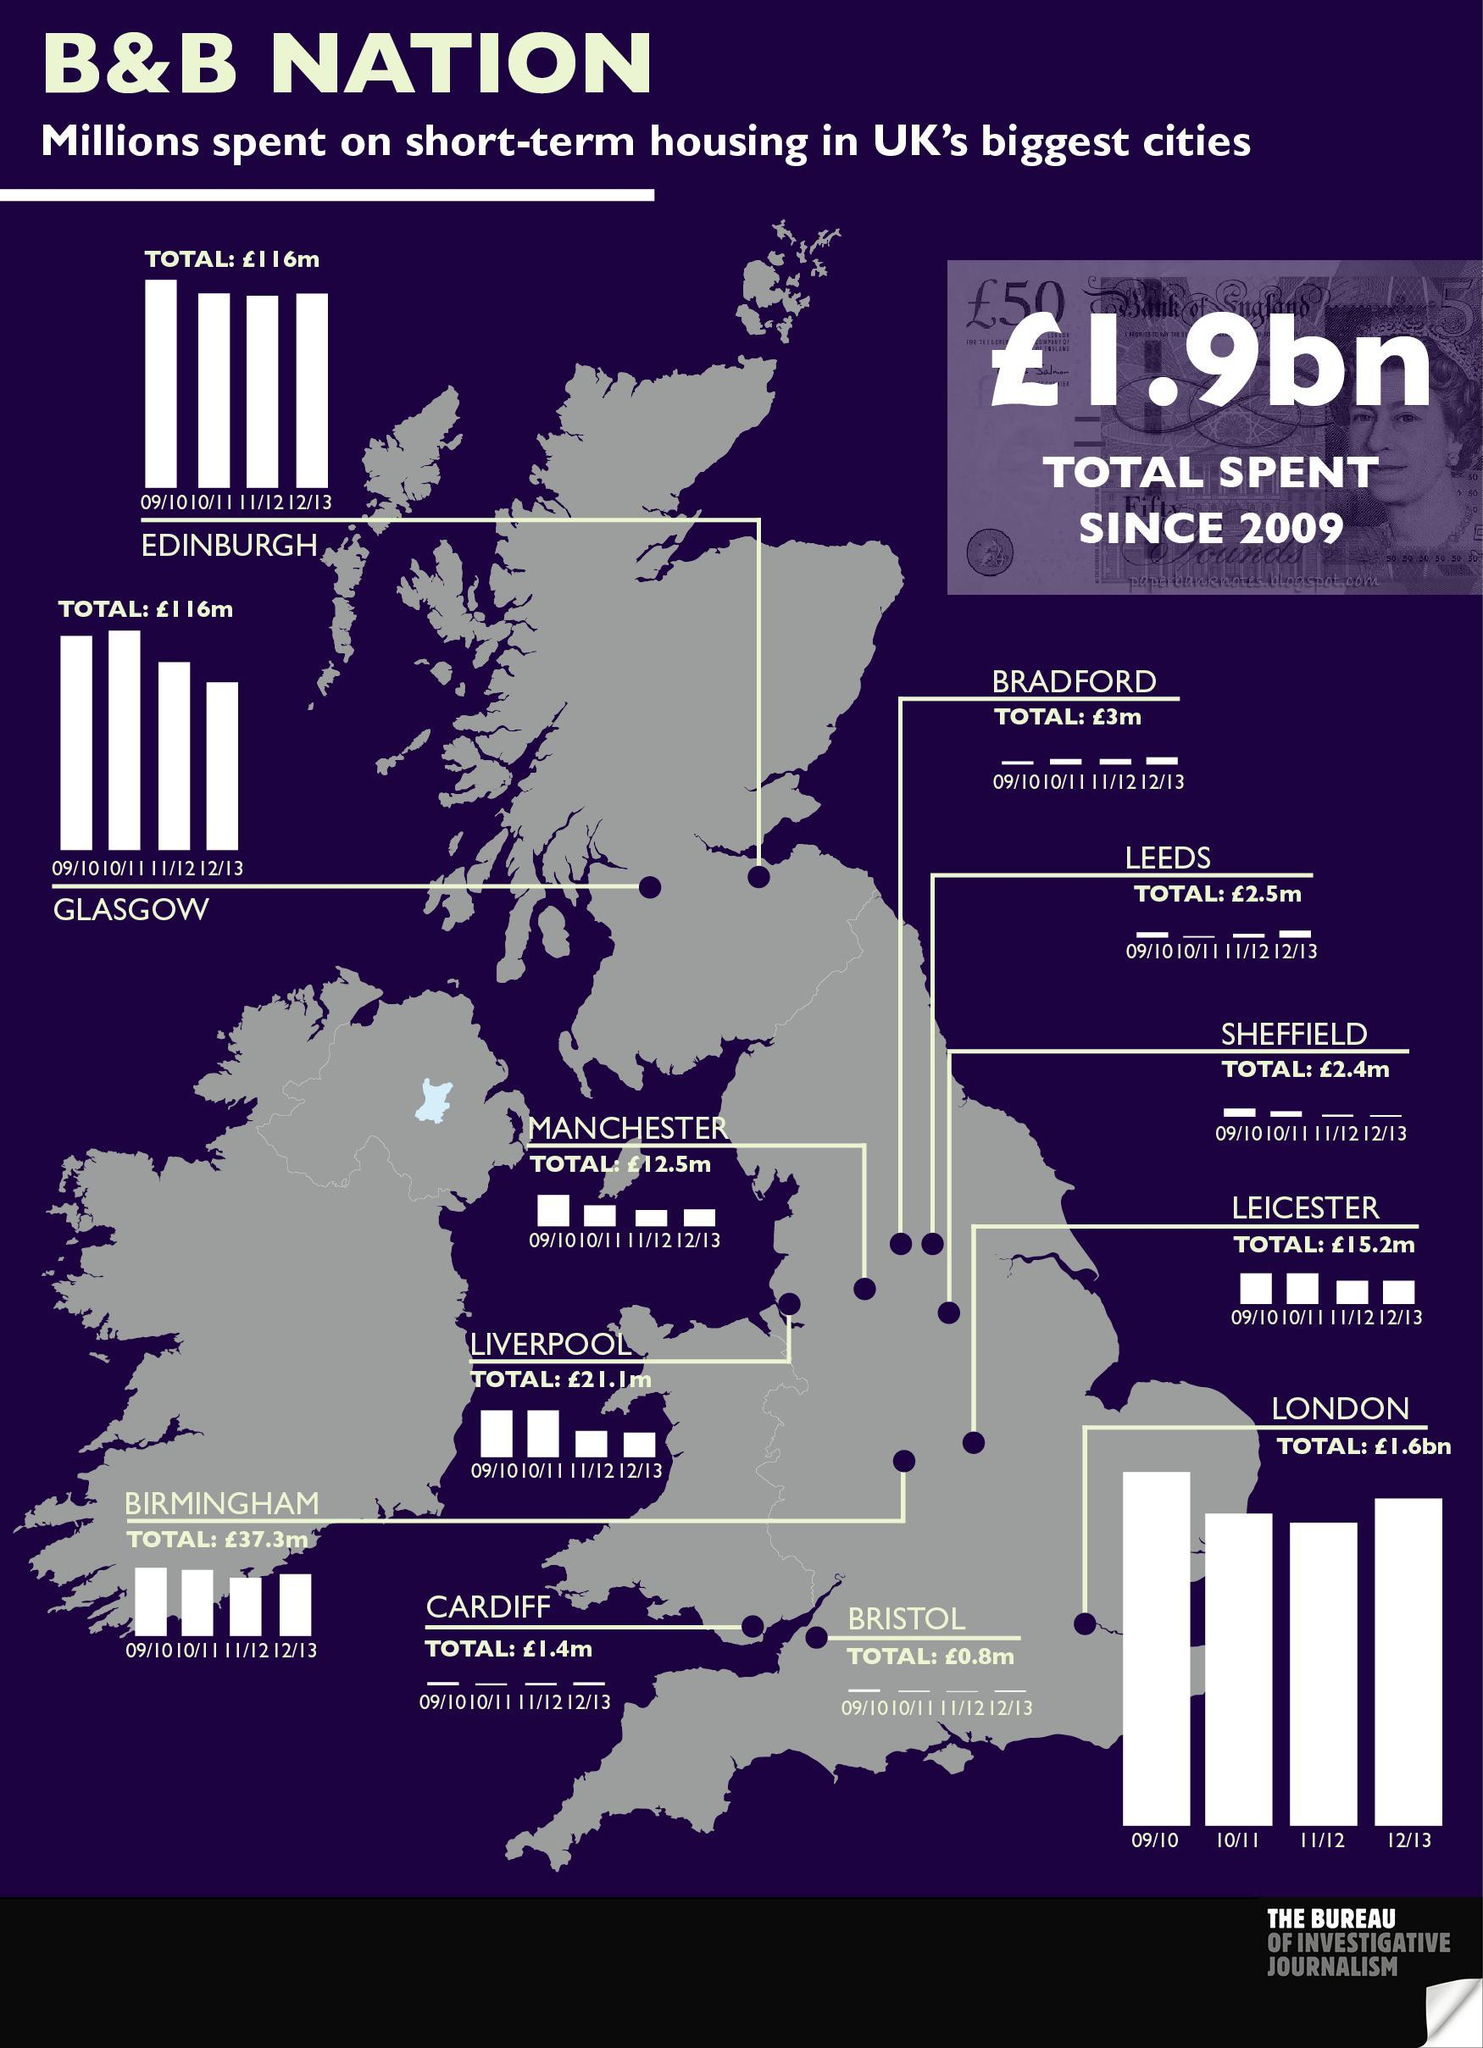Which city in UK has the highest total spend on short-term housing from 09/10 -12/13?
Answer the question with a short phrase. LONDON What is the total spend on short-term housing in Edinburgh city of UK from 09/10 -12/13? £116m What is the total spend on short-term housing in Bradford city of UK from 09/10 -12/13? £3m What is the total spend on short-term housing in Manchester city of UK from 09/10 -12/13? £12.5m 